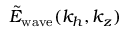<formula> <loc_0><loc_0><loc_500><loc_500>\tilde { E } _ { w a v e } ( k _ { h } , k _ { z } )</formula> 